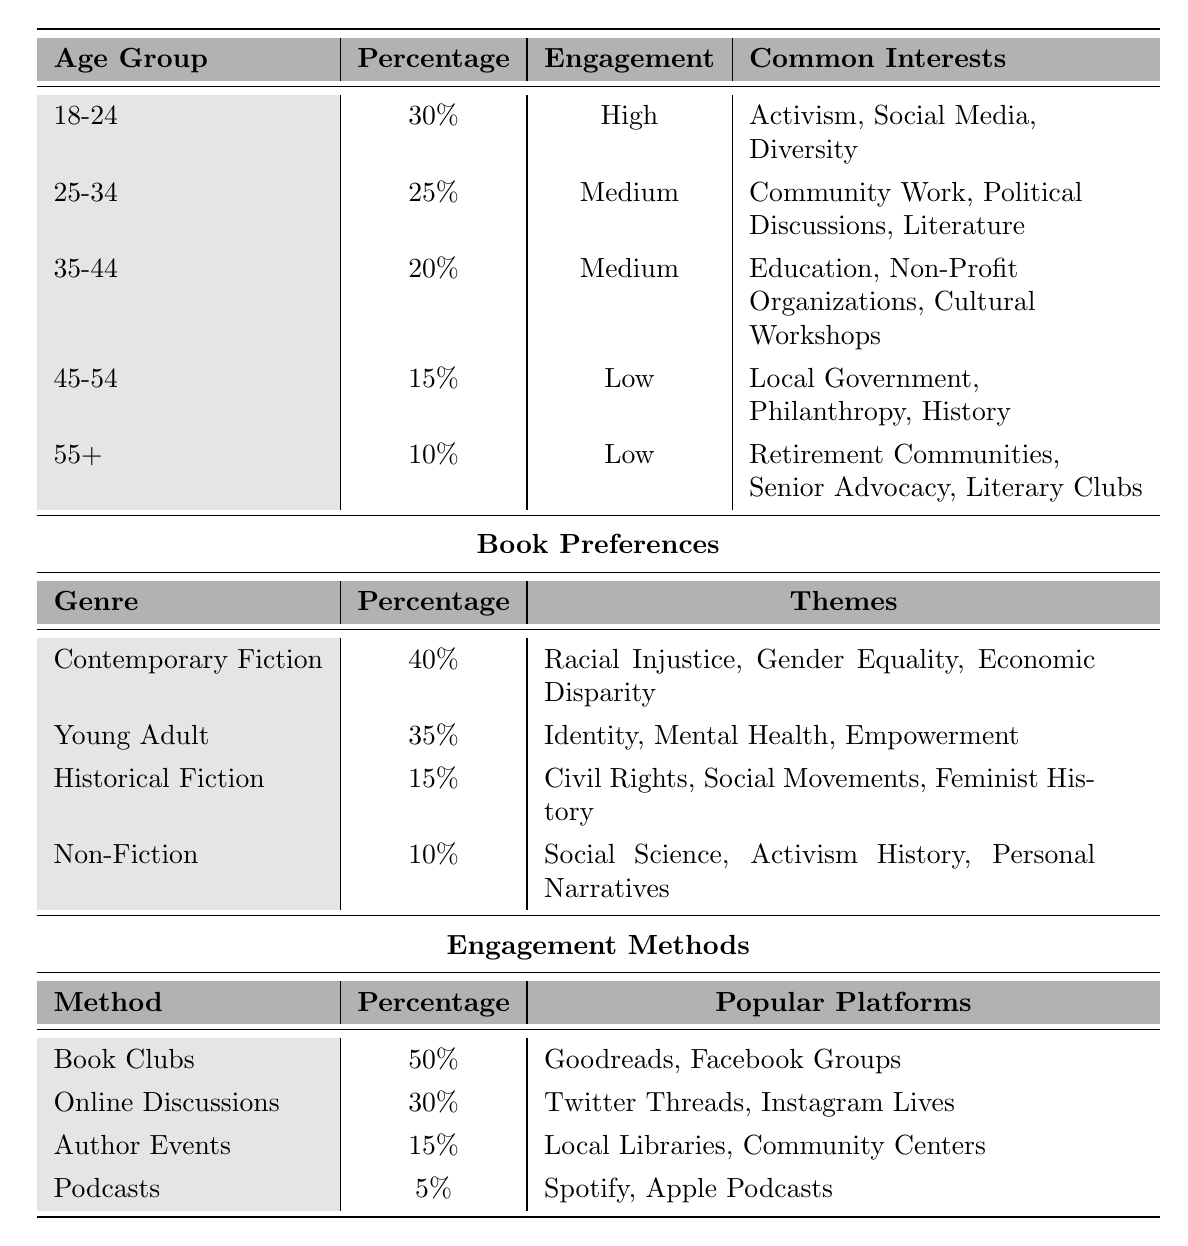What is the engagement level of the 18-24 age group? According to the table, the engagement level for the 18-24 age group is listed as "High."
Answer: High What percentage of readers are in the 35-44 age group? The table shows that 20% of readers belong to the 35-44 age group.
Answer: 20% Which genre has the highest percentage preference among readers? The table indicates that "Contemporary Fiction" has the highest percentage of 40%, making it the preferred genre among readers.
Answer: Contemporary Fiction How many percentage points separate the preferences for Young Adult and Historical Fiction genres? The preference for Young Adult is 35%, and for Historical Fiction, it is 15%. The difference is 35% - 15% = 20 percentage points.
Answer: 20 percentage points What engagement method is used by the highest percentage of readers? "Book Clubs" is the engagement method that 50% of readers prefer, according to the table.
Answer: Book Clubs Is the engagement level of the 45-54 age group higher or lower than the 55+ age group? The engagement level for the 45-54 age group is "Low," and for the 55+ age group, it is also "Low," which means they are equal.
Answer: Equal (both are Low) What is the total percentage of readers interested in Young Adult and Historical Fiction? The percentage for Young Adult is 35%, and for Historical Fiction, it is 15%. Adding these together gives 35% + 15% = 50%.
Answer: 50% Which engagement method has the lowest preference among readers? According to the table, "Podcasts" has the lowest preference, with only 5% of readers using this method.
Answer: Podcasts How would you categorize the age group with the highest engagement level? The table shows that the 18-24 age group has the highest engagement level, categorized as "High." Therefore, it's a young adult demographic actively engaged with social justice themes.
Answer: 18-24 (High Engagement) What are the common interests of the 25-34 age group? The table lists the common interests for the 25-34 age group as "Community Work, Political Discussions, Literature."
Answer: Community Work, Political Discussions, Literature What percentage of readers prefer Non-Fiction compared to Contemporary Fiction? The preference for Non-Fiction is 10%, while for Contemporary Fiction, it is 40%. The difference is 40% - 10% = 30 percentage points.
Answer: 30 percentage points Additionally, what is the median engagement level across all age groups? The engagement levels are "High," "Medium," "Medium," "Low," and "Low." The median engagement level, considering the middle value when arranged, is "Medium."
Answer: Medium 